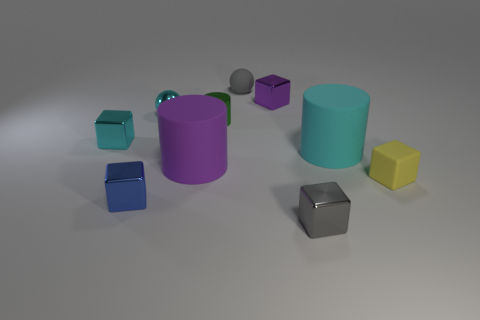There is a large thing that is made of the same material as the big purple cylinder; what color is it?
Make the answer very short. Cyan. Do the purple metallic object and the large cyan matte object have the same shape?
Offer a very short reply. No. What number of rubber objects are both behind the small yellow block and right of the small rubber sphere?
Keep it short and to the point. 1. How many rubber objects are either tiny things or purple cylinders?
Keep it short and to the point. 3. How big is the cyan thing that is behind the object on the left side of the small blue metallic block?
Offer a very short reply. Small. There is a cube that is the same color as the matte ball; what is its material?
Your answer should be very brief. Metal. Is there a small green metal cylinder that is to the right of the tiny matte object that is in front of the tiny rubber object that is behind the tiny yellow block?
Your response must be concise. No. Does the small cube that is behind the shiny sphere have the same material as the gray object in front of the yellow matte thing?
Your answer should be very brief. Yes. What number of objects are tiny blue metal cubes or large objects to the right of the gray matte sphere?
Your answer should be compact. 2. What number of other small blue metal objects have the same shape as the blue object?
Offer a terse response. 0. 